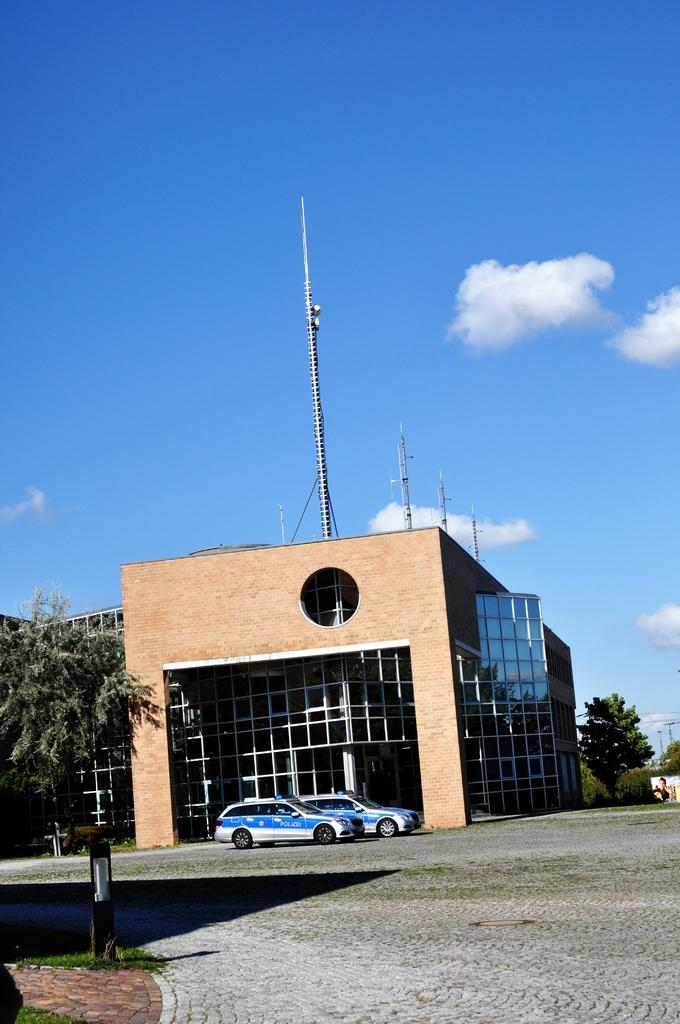What is the main subject in the center of the image? There is a house in the center of the image. What type of vehicles can be seen in the image? There are cars in the image. What type of vegetation is present in the image? There are trees in the image. What structures can be seen in the image? There are poles in the image. What is at the bottom of the image? There is a walkway and a pole at the bottom of the image. What is visible at the top of the image? The sky is visible at the top of the image. Where is the zebra located in the image? There is no zebra present in the image. What type of crate is visible in the image? There is no crate present in the image. 